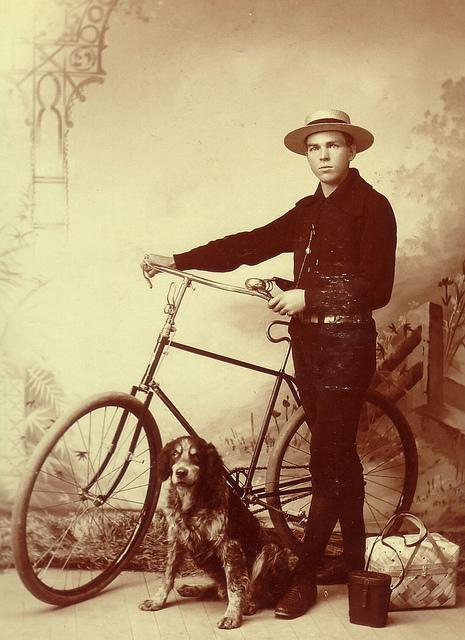What purpose is the bike serving right now?
Pick the right solution, then justify: 'Answer: answer
Rationale: rationale.'
Options: Exercise, prop, travel, commerce. Answer: prop.
Rationale: The bike owner is holding it to one side to create a pictorial detail. 